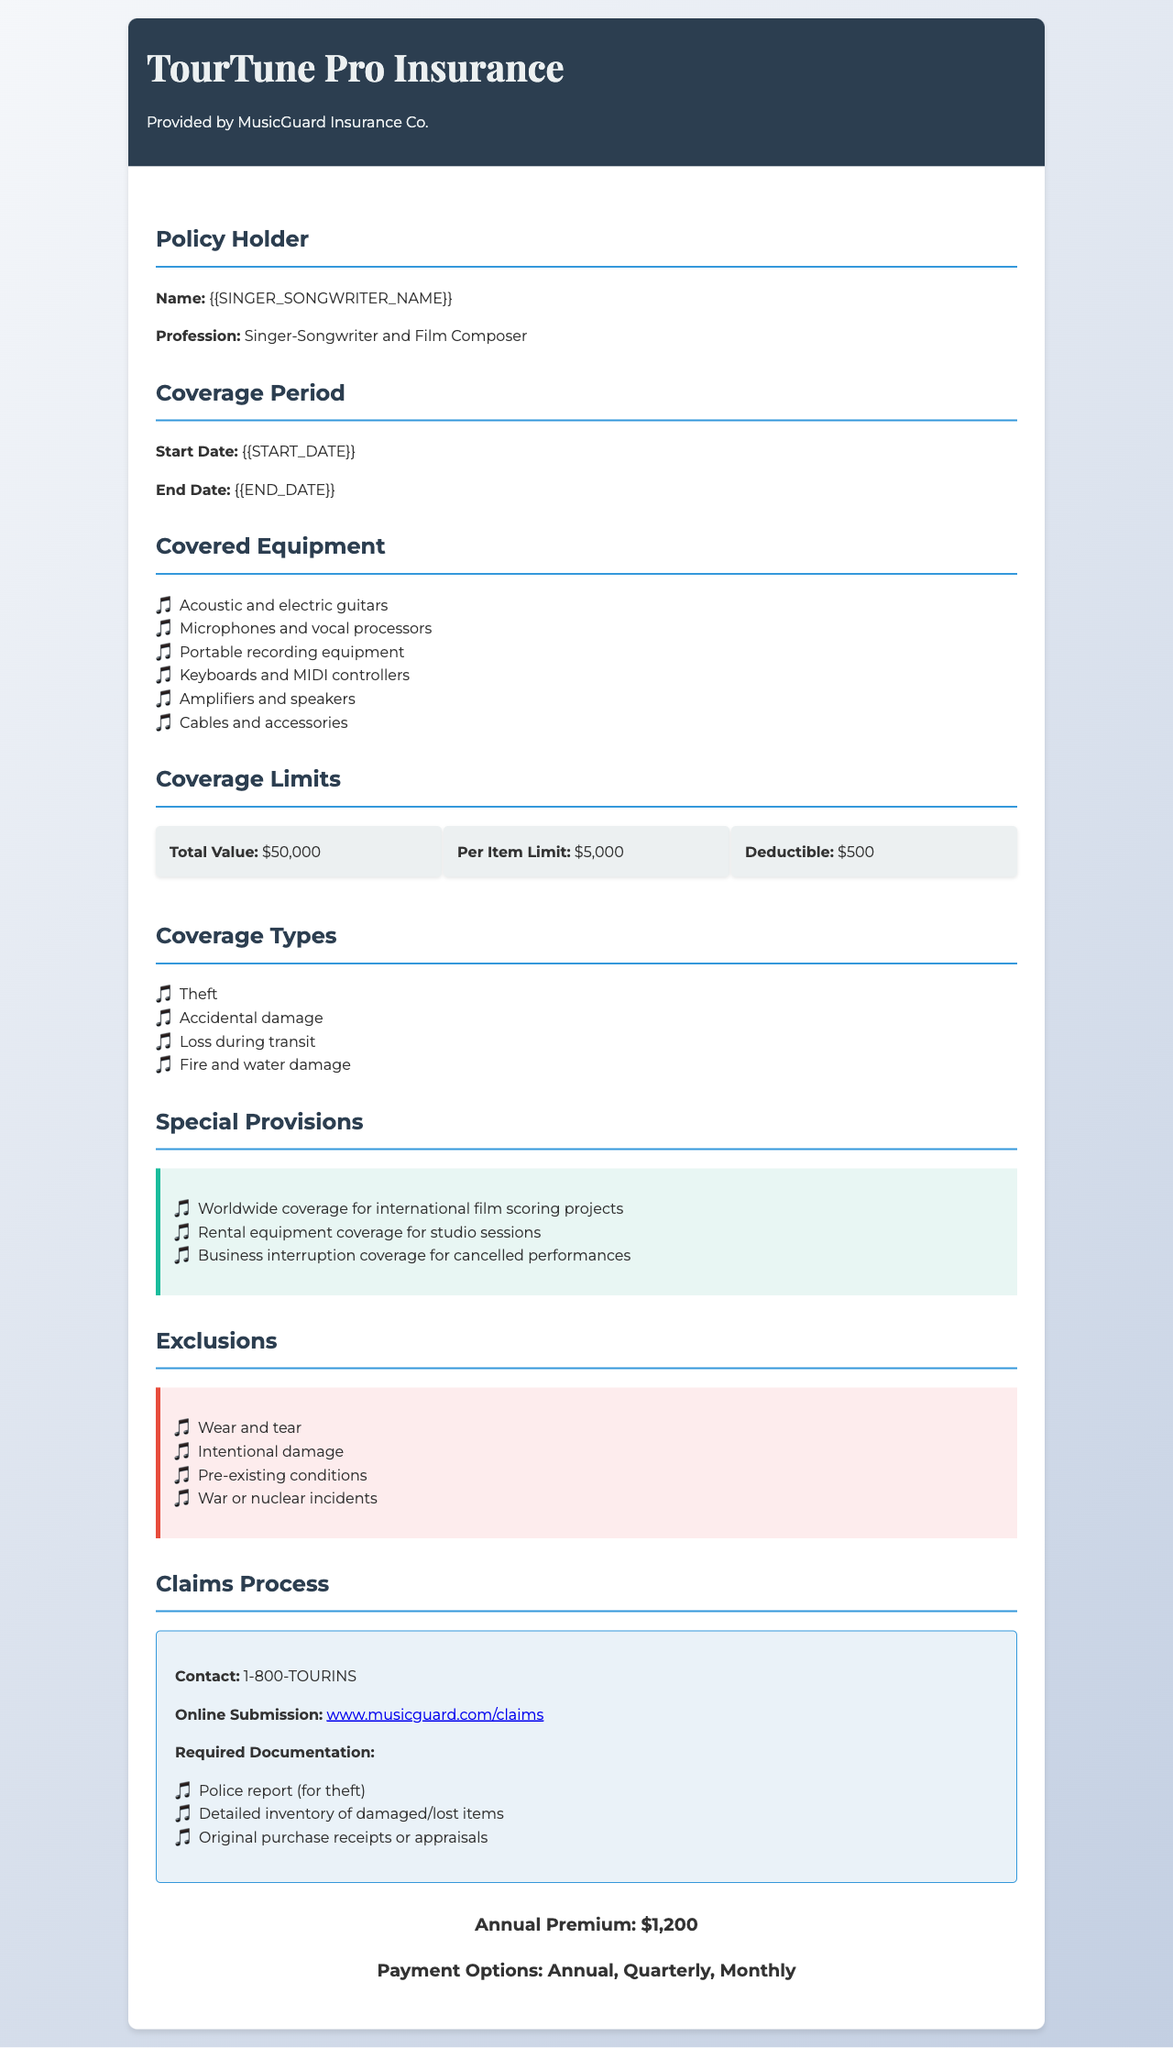What is the name of the insurance provider? The insurance is provided by MusicGuard Insurance Co. as stated in the document header.
Answer: MusicGuard Insurance Co What is the total value of coverage? The total value of coverage is specified under Coverage Limits in the document.
Answer: $50,000 What is the deductible amount? The deductible amount is mentioned in the Coverage Limits section of the document.
Answer: $500 What is the start date of the coverage period? The start date of the coverage period is outlined under the Coverage Period section.
Answer: {{START_DATE}} What type of equipment is covered? The document lists various equipment types in the Covered Equipment section.
Answer: Acoustic and electric guitars, Microphones and vocal processors, Portable recording equipment, Keyboards and MIDI controllers, Amplifiers and speakers, Cables and accessories What coverage type includes theft? Theft is listed as one of the Coverage Types in the document.
Answer: Theft What are the exclusions mentioned in the policy? The Exclusions section of the document outlines various exclusions.
Answer: Wear and tear, Intentional damage, Pre-existing conditions, War or nuclear incidents What is the annual premium amount? The annual premium is detailed in the Premium section of the document.
Answer: $1,200 What special provision pertains to international projects? The special provision for international projects is mentioned in the Special Provisions section.
Answer: Worldwide coverage for international film scoring projects 